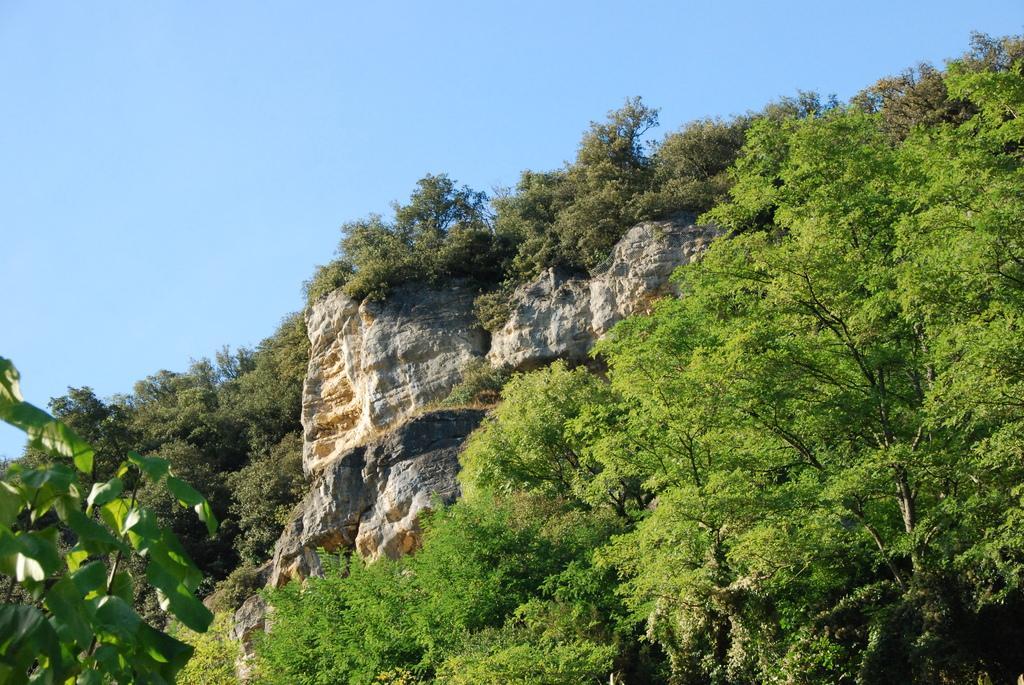How would you summarize this image in a sentence or two? In this image we can see trees and hill. In the background there is sky. 